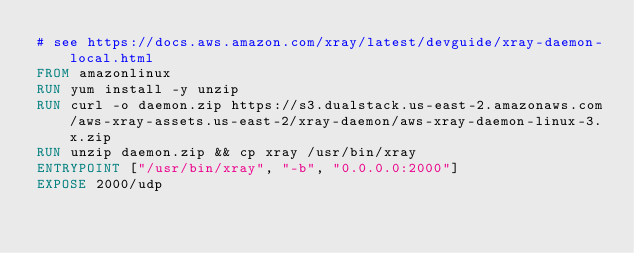Convert code to text. <code><loc_0><loc_0><loc_500><loc_500><_Dockerfile_># see https://docs.aws.amazon.com/xray/latest/devguide/xray-daemon-local.html
FROM amazonlinux
RUN yum install -y unzip
RUN curl -o daemon.zip https://s3.dualstack.us-east-2.amazonaws.com/aws-xray-assets.us-east-2/xray-daemon/aws-xray-daemon-linux-3.x.zip
RUN unzip daemon.zip && cp xray /usr/bin/xray
ENTRYPOINT ["/usr/bin/xray", "-b", "0.0.0.0:2000"]
EXPOSE 2000/udp</code> 